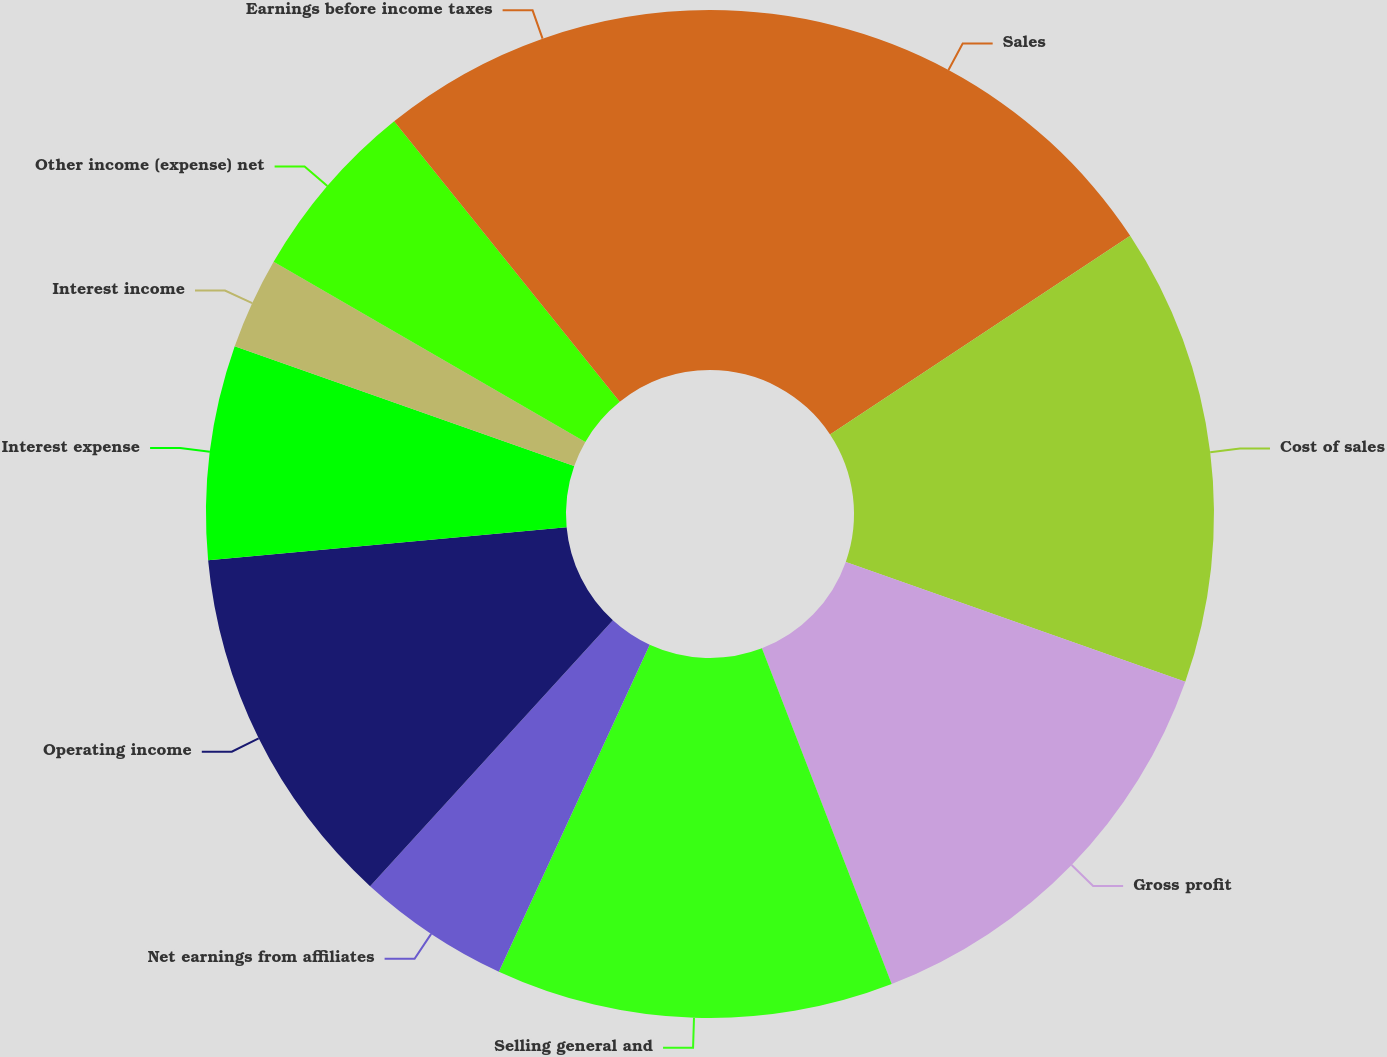Convert chart. <chart><loc_0><loc_0><loc_500><loc_500><pie_chart><fcel>Sales<fcel>Cost of sales<fcel>Gross profit<fcel>Selling general and<fcel>Net earnings from affiliates<fcel>Operating income<fcel>Interest expense<fcel>Interest income<fcel>Other income (expense) net<fcel>Earnings before income taxes<nl><fcel>15.69%<fcel>14.71%<fcel>13.73%<fcel>12.75%<fcel>4.9%<fcel>11.76%<fcel>6.86%<fcel>2.94%<fcel>5.88%<fcel>10.78%<nl></chart> 